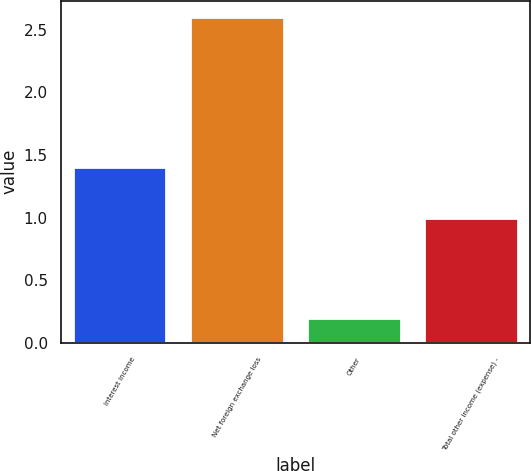<chart> <loc_0><loc_0><loc_500><loc_500><bar_chart><fcel>Interest income<fcel>Net foreign exchange loss<fcel>Other<fcel>Total other income (expense) -<nl><fcel>1.4<fcel>2.6<fcel>0.2<fcel>1<nl></chart> 